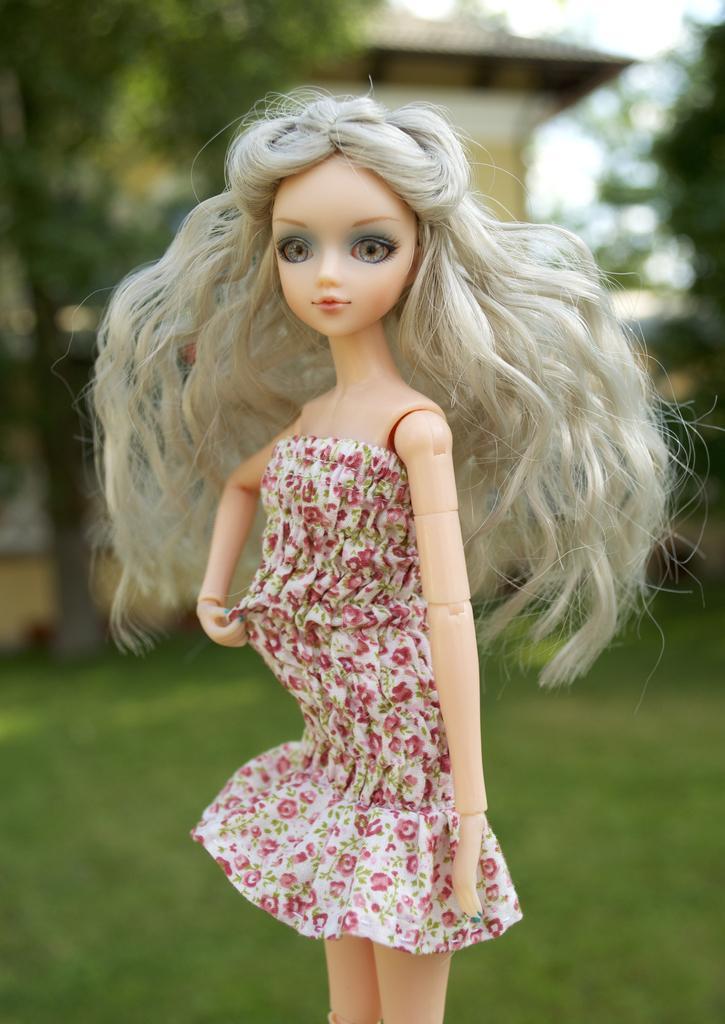How would you summarize this image in a sentence or two? In this image in the front there is a doll. In the background there is grass, there are trees and there is a house. 